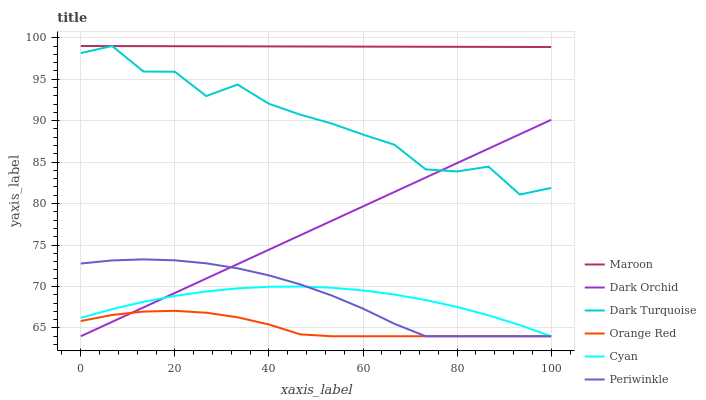Does Orange Red have the minimum area under the curve?
Answer yes or no. Yes. Does Maroon have the maximum area under the curve?
Answer yes or no. Yes. Does Dark Orchid have the minimum area under the curve?
Answer yes or no. No. Does Dark Orchid have the maximum area under the curve?
Answer yes or no. No. Is Maroon the smoothest?
Answer yes or no. Yes. Is Dark Turquoise the roughest?
Answer yes or no. Yes. Is Dark Orchid the smoothest?
Answer yes or no. No. Is Dark Orchid the roughest?
Answer yes or no. No. Does Dark Orchid have the lowest value?
Answer yes or no. Yes. Does Maroon have the lowest value?
Answer yes or no. No. Does Maroon have the highest value?
Answer yes or no. Yes. Does Dark Orchid have the highest value?
Answer yes or no. No. Is Dark Orchid less than Maroon?
Answer yes or no. Yes. Is Maroon greater than Dark Orchid?
Answer yes or no. Yes. Does Dark Turquoise intersect Dark Orchid?
Answer yes or no. Yes. Is Dark Turquoise less than Dark Orchid?
Answer yes or no. No. Is Dark Turquoise greater than Dark Orchid?
Answer yes or no. No. Does Dark Orchid intersect Maroon?
Answer yes or no. No. 